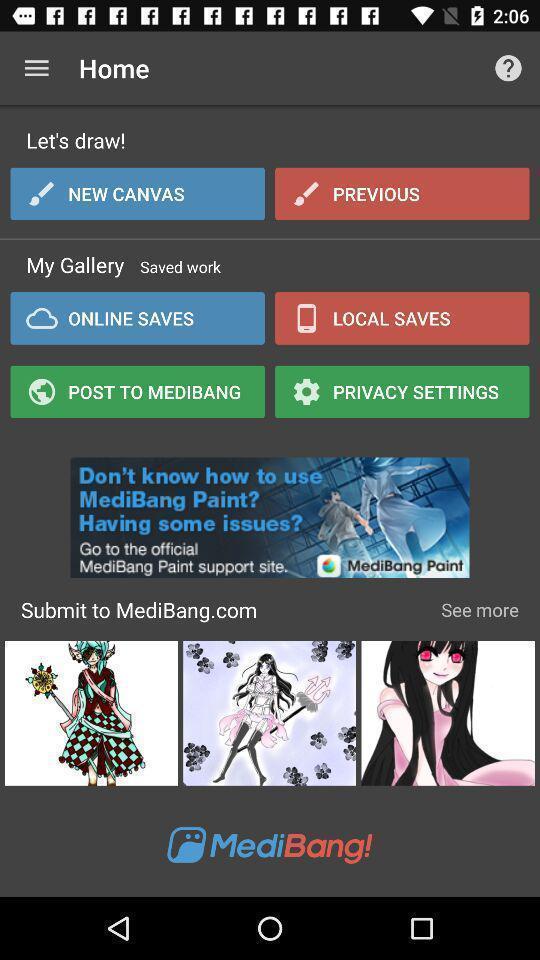Describe the key features of this screenshot. Screen displaying the page of a painting app. 